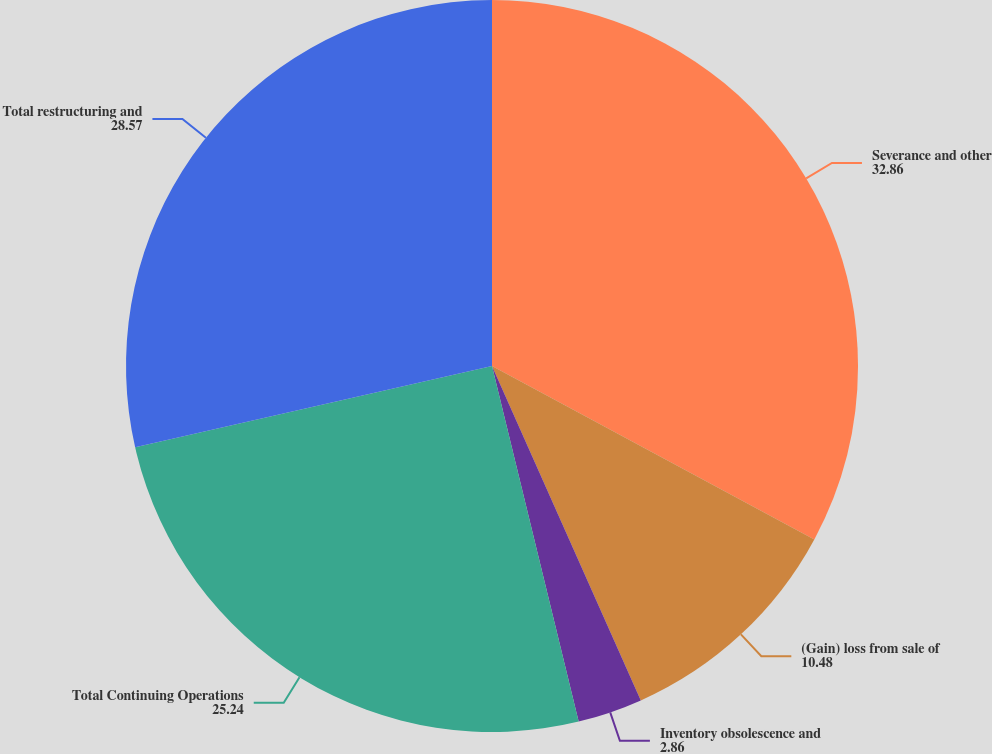Convert chart. <chart><loc_0><loc_0><loc_500><loc_500><pie_chart><fcel>Severance and other<fcel>(Gain) loss from sale of<fcel>Inventory obsolescence and<fcel>Total Continuing Operations<fcel>Total restructuring and<nl><fcel>32.86%<fcel>10.48%<fcel>2.86%<fcel>25.24%<fcel>28.57%<nl></chart> 